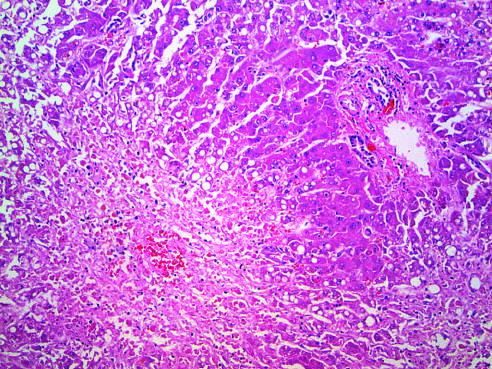s hepatocellular necrosis caused by acetaminophen overdose?
Answer the question using a single word or phrase. Yes 